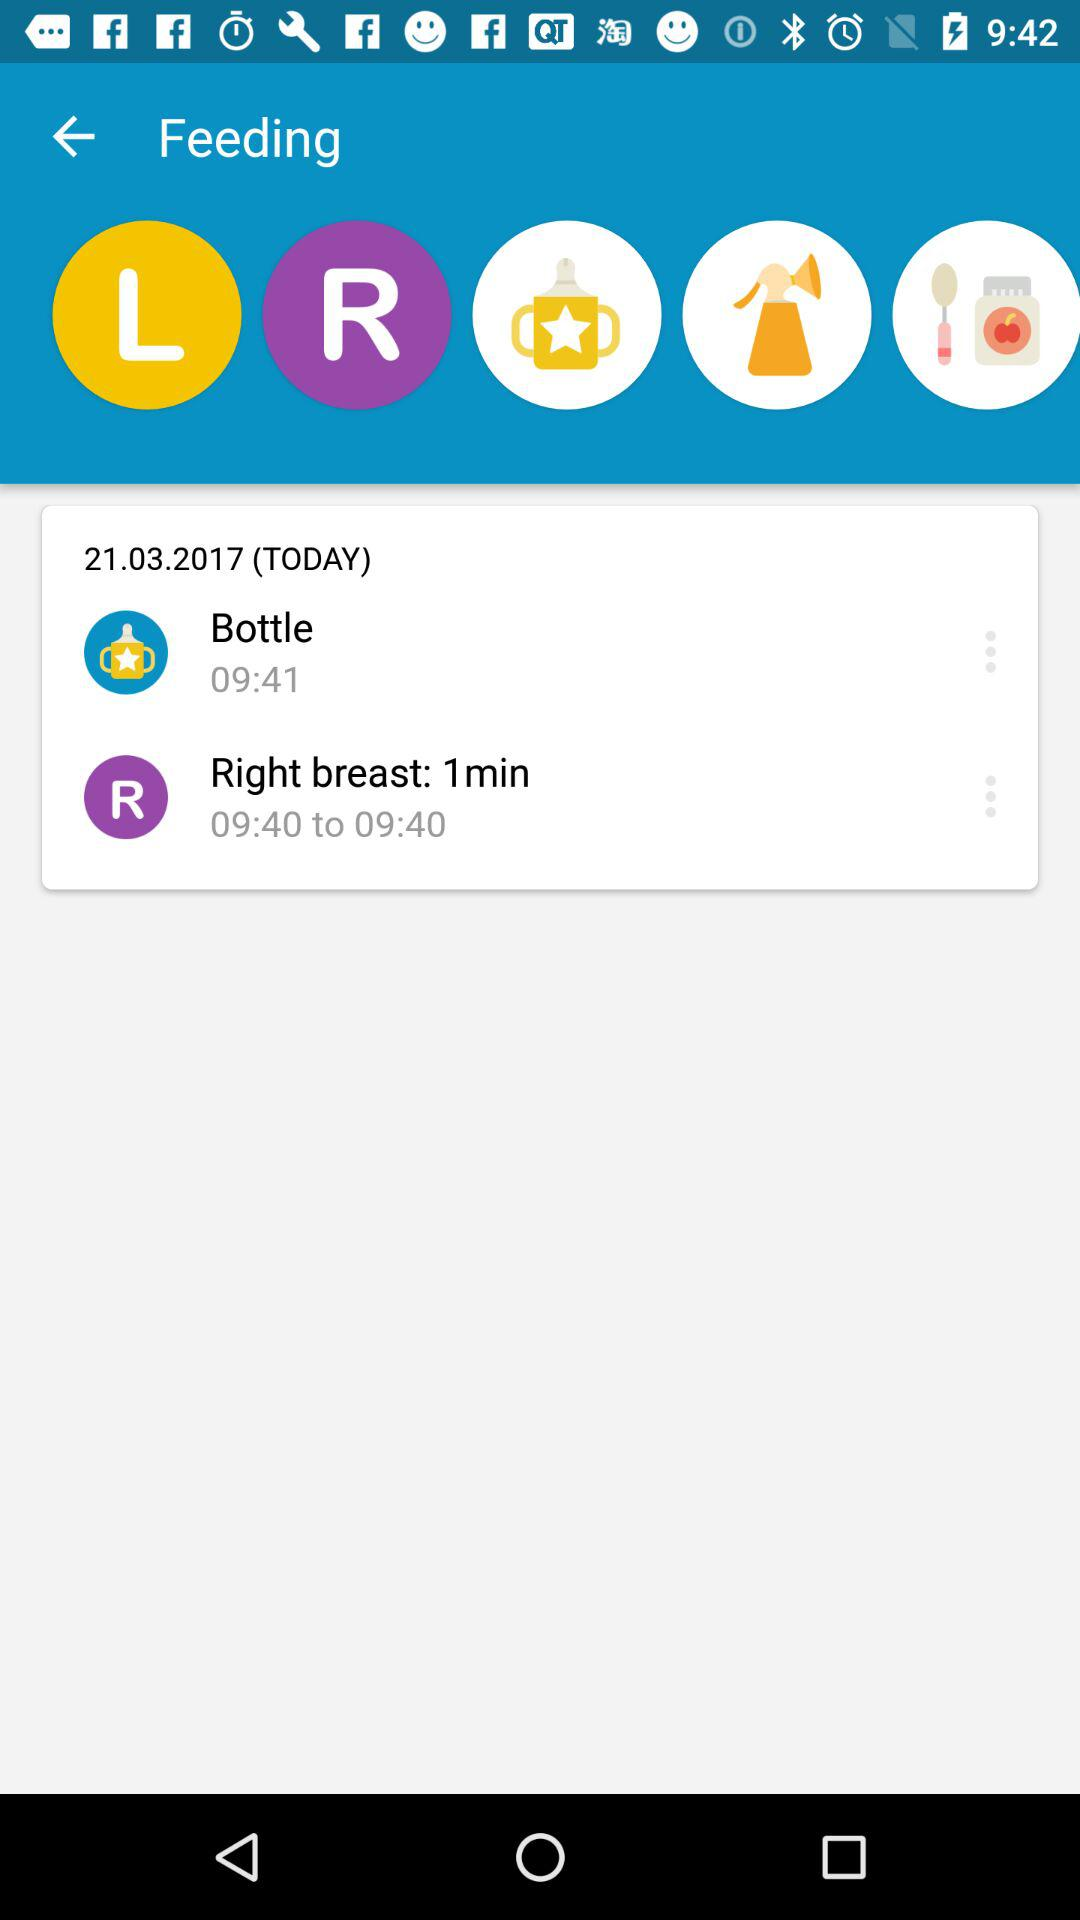What is the time of bottle feeding? The time of bottle feeding is 09:41. 